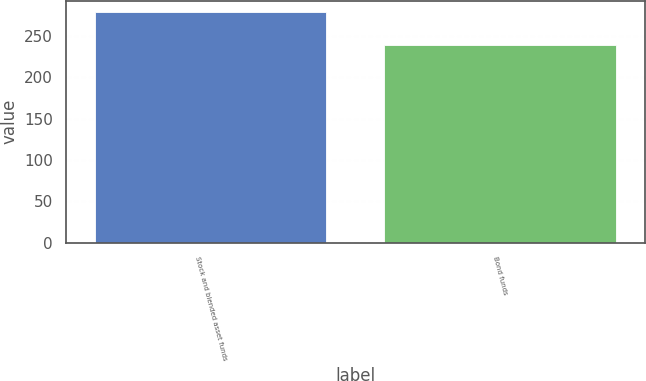<chart> <loc_0><loc_0><loc_500><loc_500><bar_chart><fcel>Stock and blended asset funds<fcel>Bond funds<nl><fcel>278.6<fcel>238.9<nl></chart> 